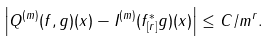<formula> <loc_0><loc_0><loc_500><loc_500>\left | Q ^ { ( m ) } ( f , g ) ( x ) - I ^ { ( m ) } ( f ^ { * } _ { [ r ] } g ) ( x ) \right | \leq C / m ^ { r } .</formula> 